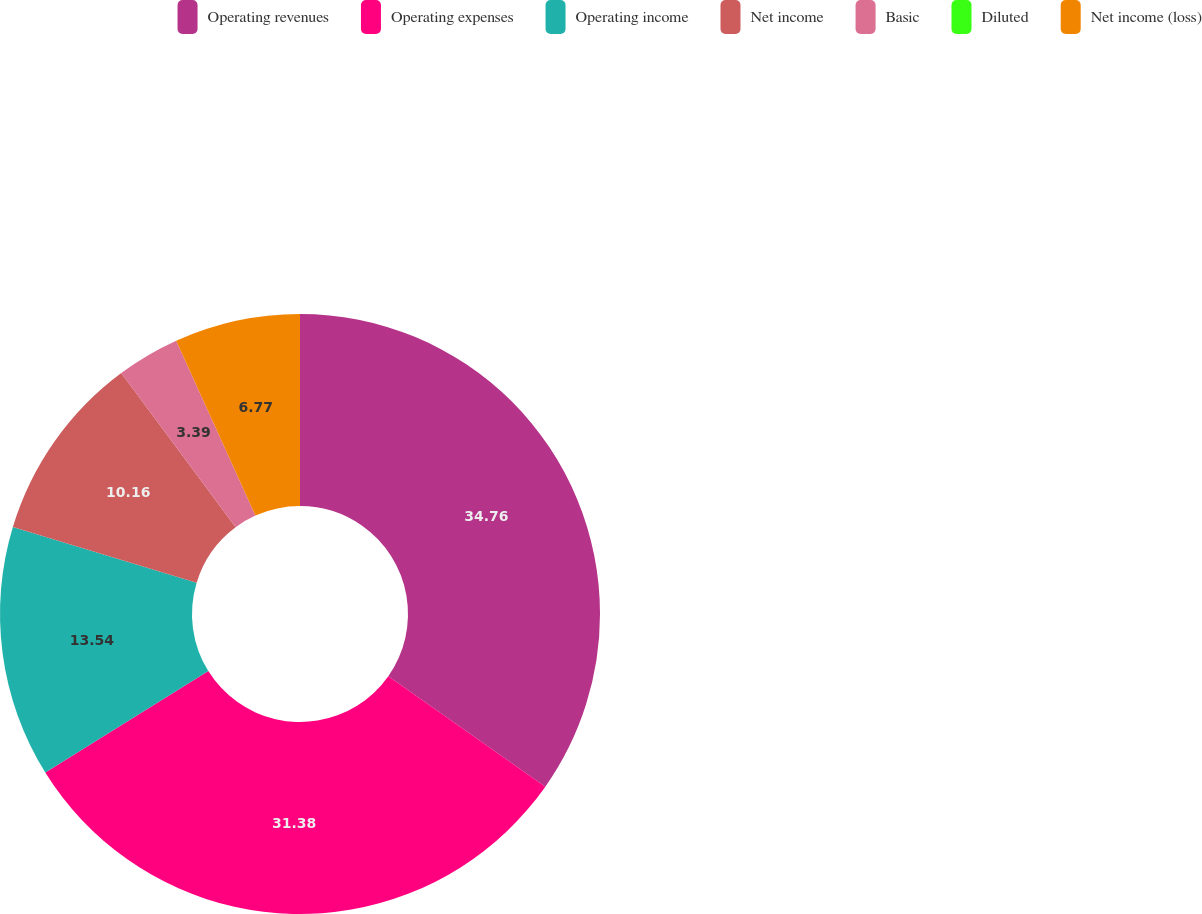<chart> <loc_0><loc_0><loc_500><loc_500><pie_chart><fcel>Operating revenues<fcel>Operating expenses<fcel>Operating income<fcel>Net income<fcel>Basic<fcel>Diluted<fcel>Net income (loss)<nl><fcel>34.76%<fcel>31.38%<fcel>13.54%<fcel>10.16%<fcel>3.39%<fcel>0.0%<fcel>6.77%<nl></chart> 